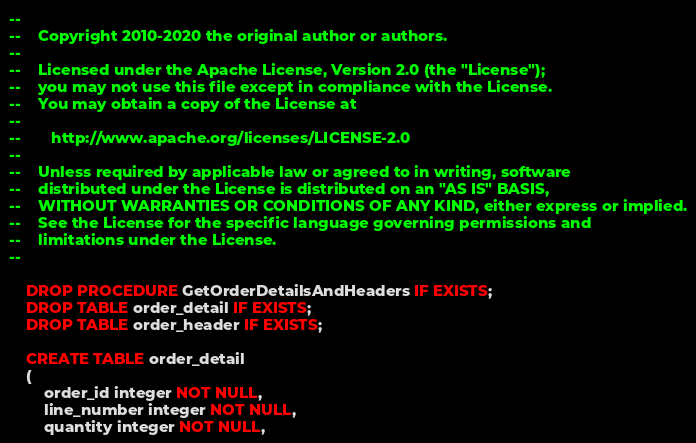<code> <loc_0><loc_0><loc_500><loc_500><_SQL_>--
--    Copyright 2010-2020 the original author or authors.
--
--    Licensed under the Apache License, Version 2.0 (the "License");
--    you may not use this file except in compliance with the License.
--    You may obtain a copy of the License at
--
--       http://www.apache.org/licenses/LICENSE-2.0
--
--    Unless required by applicable law or agreed to in writing, software
--    distributed under the License is distributed on an "AS IS" BASIS,
--    WITHOUT WARRANTIES OR CONDITIONS OF ANY KIND, either express or implied.
--    See the License for the specific language governing permissions and
--    limitations under the License.
--

    DROP PROCEDURE GetOrderDetailsAndHeaders IF EXISTS;
    DROP TABLE order_detail IF EXISTS;
    DROP TABLE order_header IF EXISTS;

    CREATE TABLE order_detail
    (
        order_id integer NOT NULL,
        line_number integer NOT NULL,
        quantity integer NOT NULL,</code> 